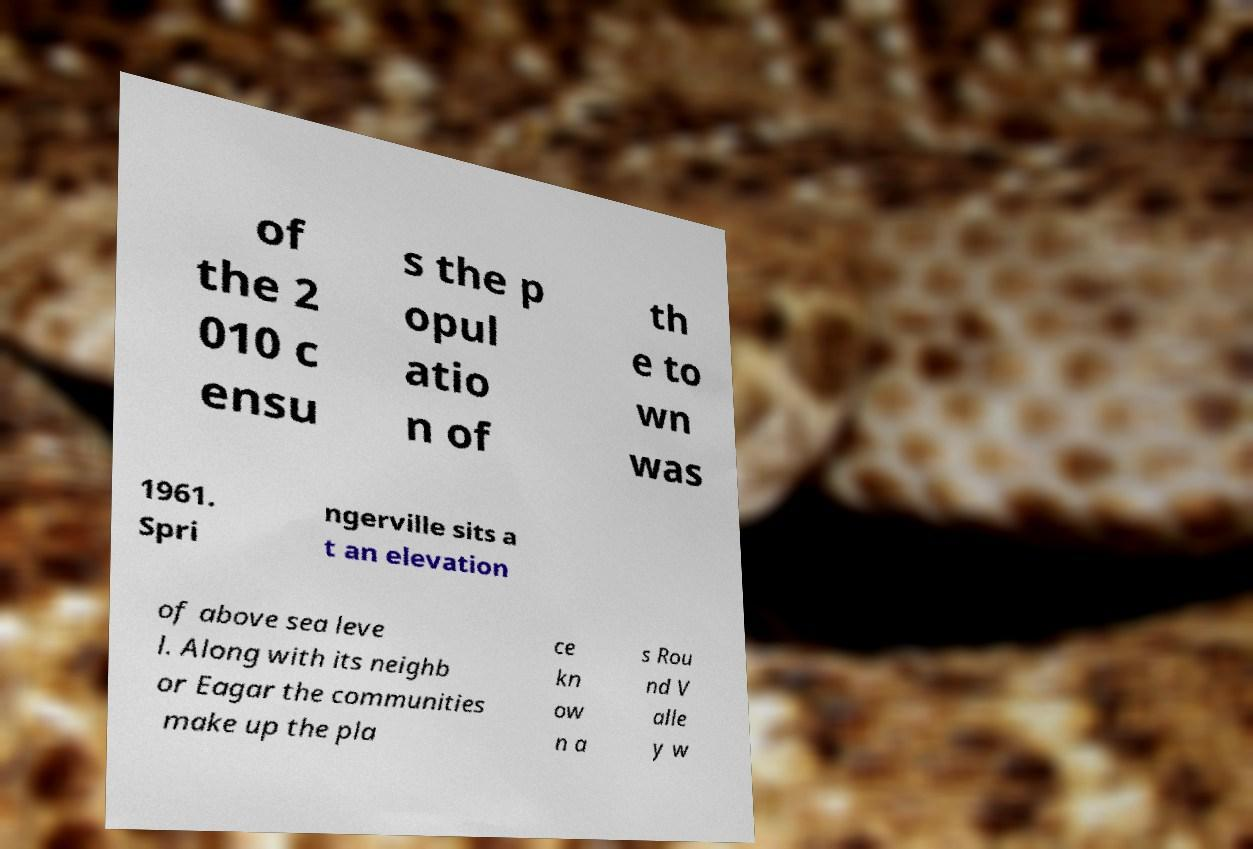What messages or text are displayed in this image? I need them in a readable, typed format. of the 2 010 c ensu s the p opul atio n of th e to wn was 1961. Spri ngerville sits a t an elevation of above sea leve l. Along with its neighb or Eagar the communities make up the pla ce kn ow n a s Rou nd V alle y w 